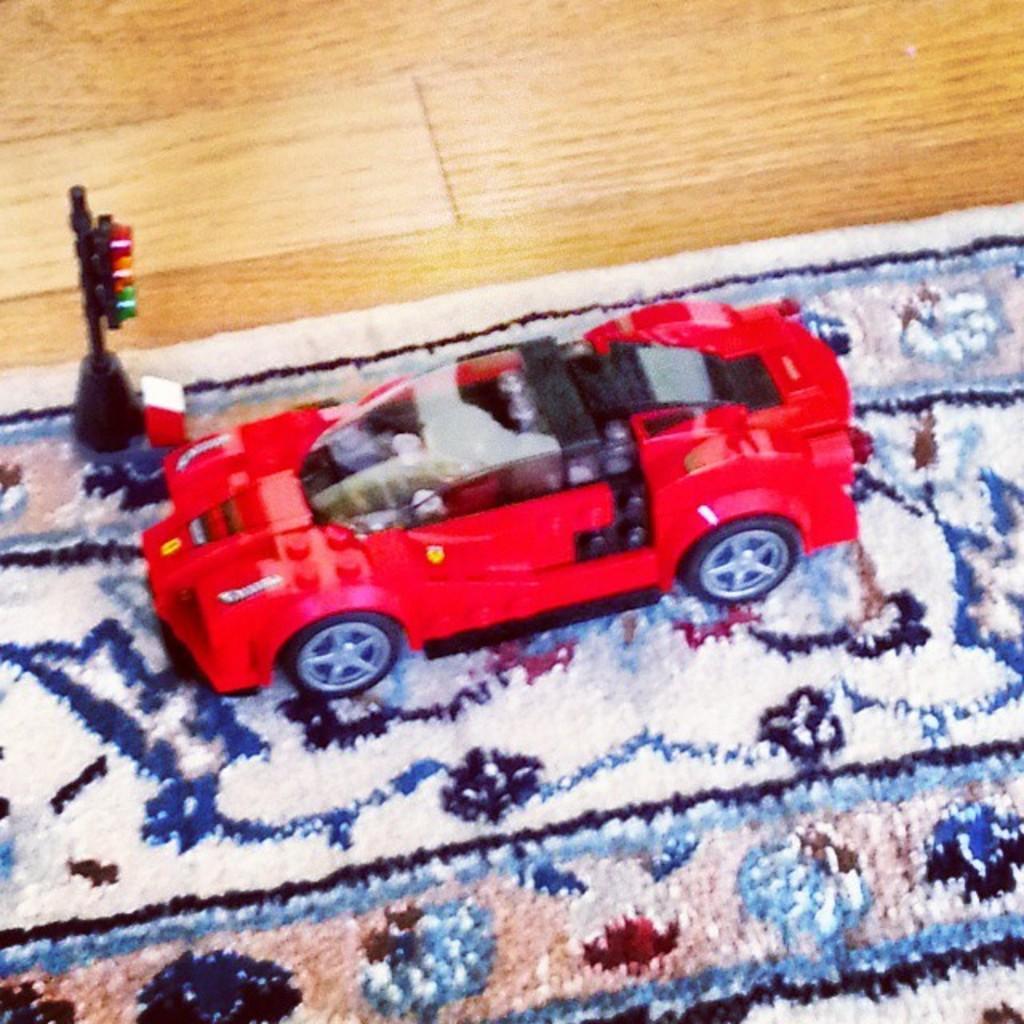Can you describe this image briefly? In this image we can see toy car and signal lights are kept on the carpet. 